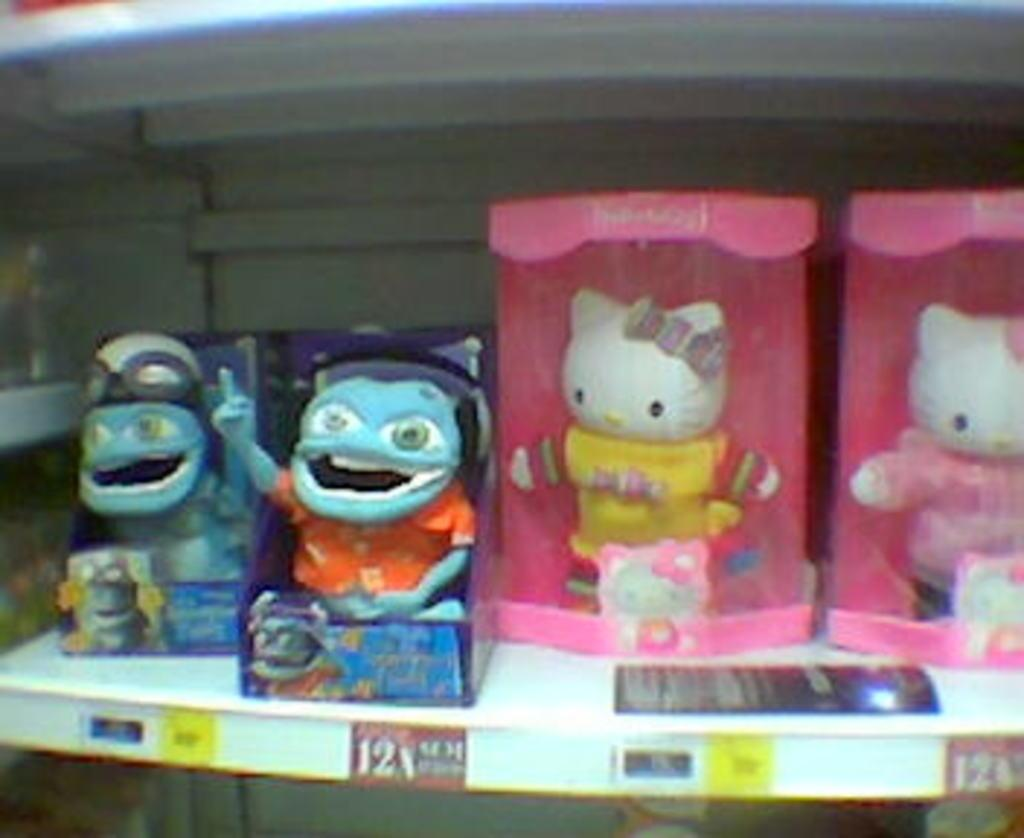What type of objects can be seen in the image? There are dolls in the image. What is the rack used for in the image? The rack is used to hold the dolls in the image. Which specific dolls are present on the rack? Hello Kitty dolls are present on the rack. How many cattle can be seen grazing in the image? There are no cattle present in the image; it features dolls and a rack. What type of straw is used to decorate the dolls in the image? There is no straw present in the image; it only features dolls and a rack. 